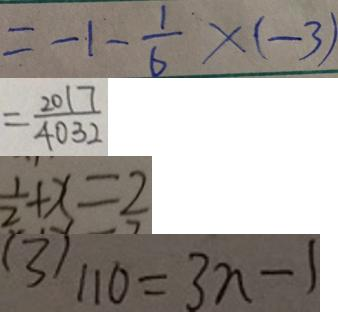<formula> <loc_0><loc_0><loc_500><loc_500>= - 1 - \frac { 1 } { 6 } \times ( - 3 ) 
 = \frac { 2 0 1 7 } { 4 0 3 2 } 
 \frac { 1 } { 2 } + x = 2 
 ( 3 ) 1 1 0 = 3 n - 1</formula> 